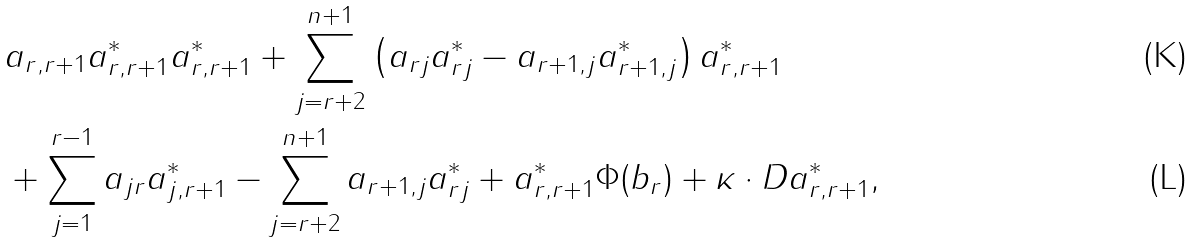<formula> <loc_0><loc_0><loc_500><loc_500>& \quad a _ { r , r + 1 } a ^ { * } _ { r , r + 1 } a ^ { * } _ { r , r + 1 } + \sum _ { j = r + 2 } ^ { n + 1 } \left ( a _ { r j } a ^ { * } _ { r j } - a _ { r + 1 , j } a ^ { * } _ { r + 1 , j } \right ) a ^ { * } _ { r , r + 1 } \\ & \quad + \sum _ { j = 1 } ^ { r - 1 } a _ { j r } a ^ { * } _ { j , r + 1 } - \sum _ { j = r + 2 } ^ { n + 1 } a _ { r + 1 , j } a _ { r j } ^ { * } + a _ { r , r + 1 } ^ { * } \Phi ( b _ { r } ) + \kappa \cdot D a _ { r , r + 1 } ^ { * } ,</formula> 